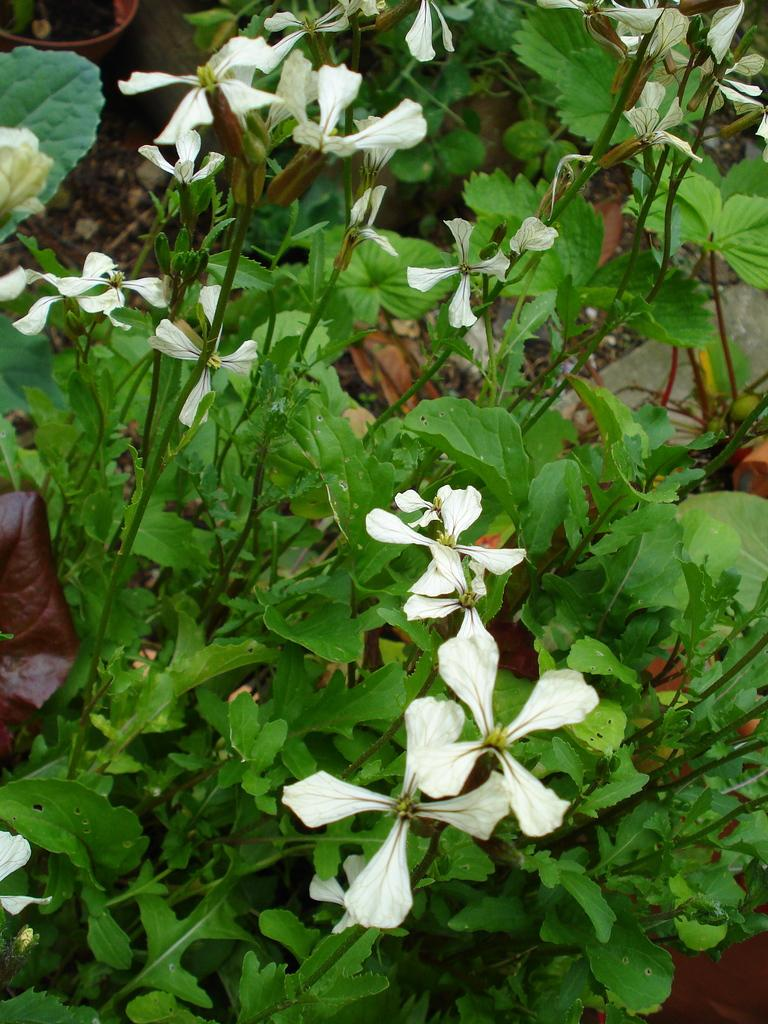What color are the flowers in the image? The flowers in the image are white. What type of plant do the flowers belong to? The flowers belong to a plant. What can be seen in the image that is used for holding plants? There are flower pots in the image. What type of society is depicted in the image? There is no society depicted in the image; it features white color flowers, a plant, and flower pots. What role does zinc play in the image? There is no mention of zinc in the image; it focuses on flowers, a plant, and flower pots. 